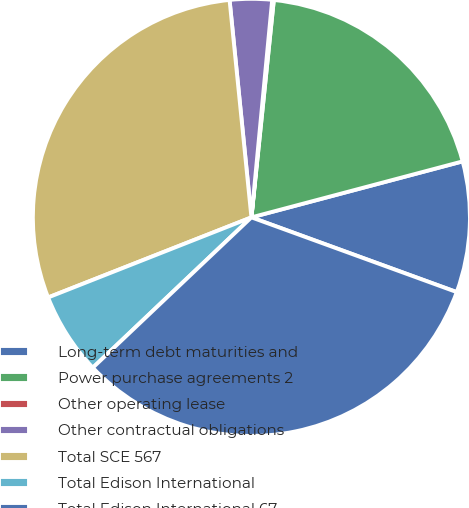Convert chart. <chart><loc_0><loc_0><loc_500><loc_500><pie_chart><fcel>Long-term debt maturities and<fcel>Power purchase agreements 2<fcel>Other operating lease<fcel>Other contractual obligations<fcel>Total SCE 567<fcel>Total Edison International<fcel>Total Edison International 67<nl><fcel>9.68%<fcel>19.24%<fcel>0.12%<fcel>3.11%<fcel>29.38%<fcel>6.1%<fcel>32.37%<nl></chart> 